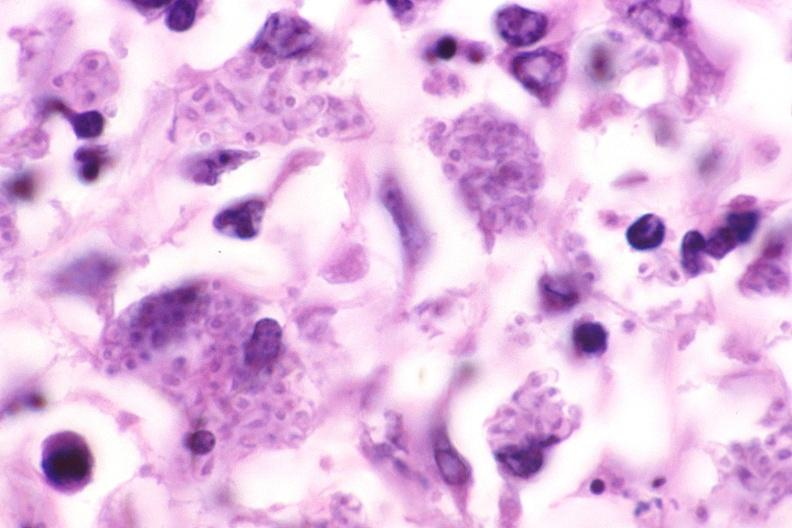where is this?
Answer the question using a single word or phrase. Lung 